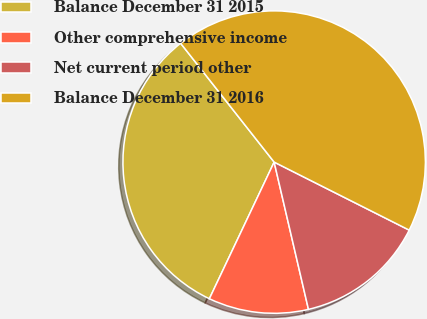<chart> <loc_0><loc_0><loc_500><loc_500><pie_chart><fcel>Balance December 31 2015<fcel>Other comprehensive income<fcel>Net current period other<fcel>Balance December 31 2016<nl><fcel>32.34%<fcel>10.69%<fcel>13.93%<fcel>43.04%<nl></chart> 